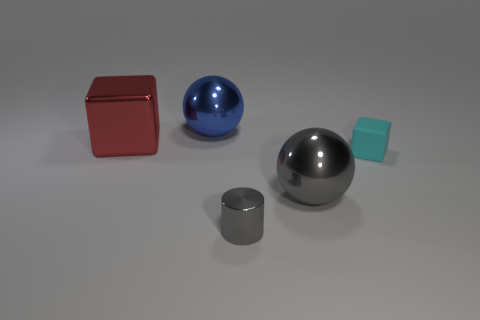Subtract all red balls. Subtract all yellow blocks. How many balls are left? 2 Add 5 large green balls. How many objects exist? 10 Subtract all cylinders. How many objects are left? 4 Subtract all balls. Subtract all red metallic cubes. How many objects are left? 2 Add 4 tiny cyan objects. How many tiny cyan objects are left? 5 Add 5 large brown shiny objects. How many large brown shiny objects exist? 5 Subtract 0 yellow cylinders. How many objects are left? 5 